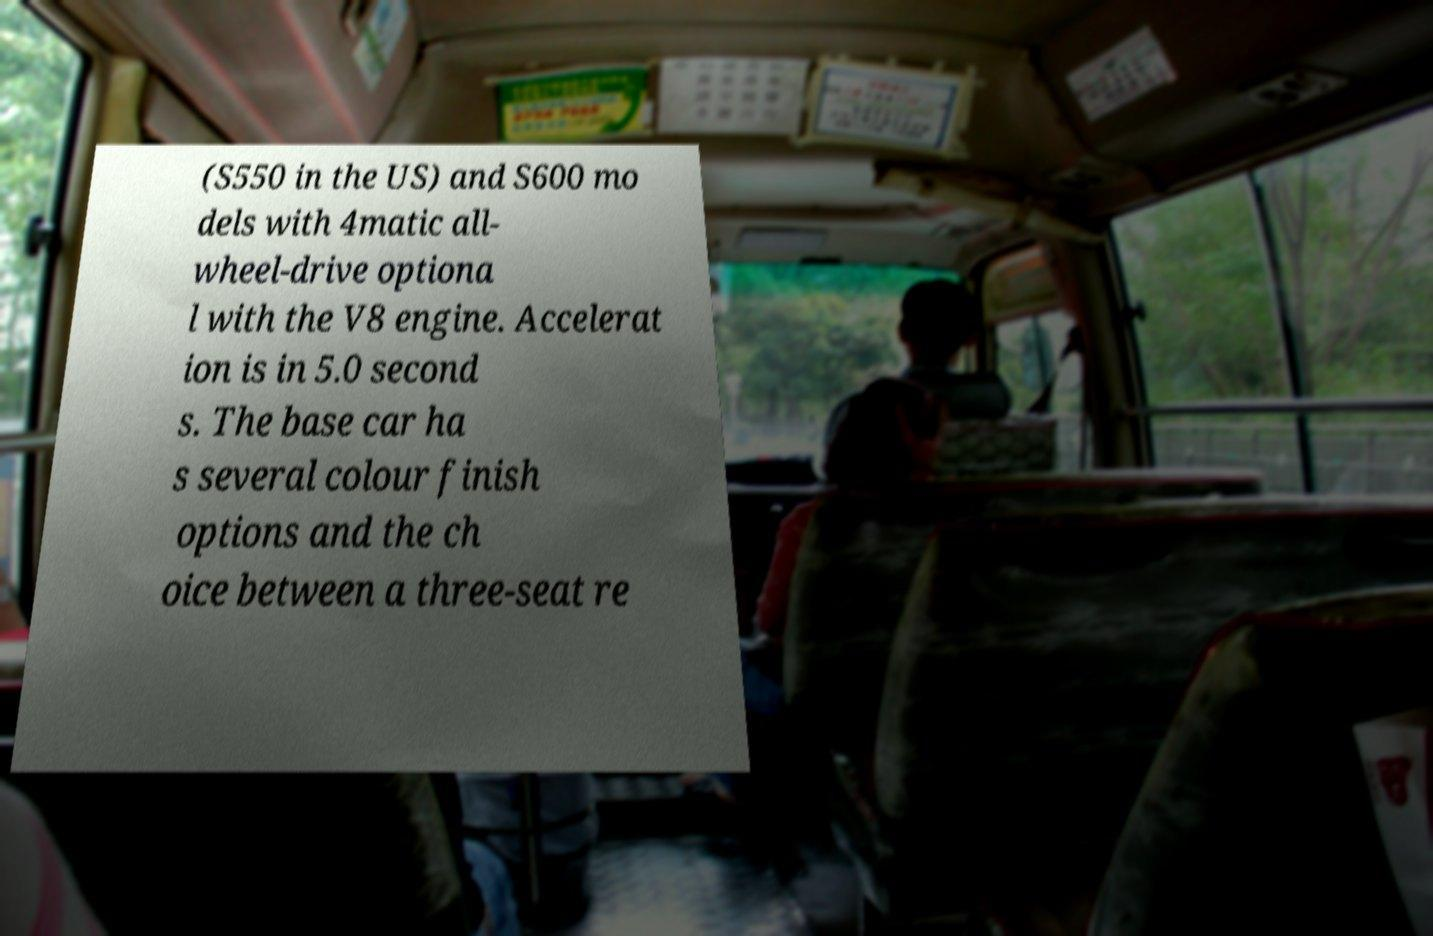Please identify and transcribe the text found in this image. (S550 in the US) and S600 mo dels with 4matic all- wheel-drive optiona l with the V8 engine. Accelerat ion is in 5.0 second s. The base car ha s several colour finish options and the ch oice between a three-seat re 